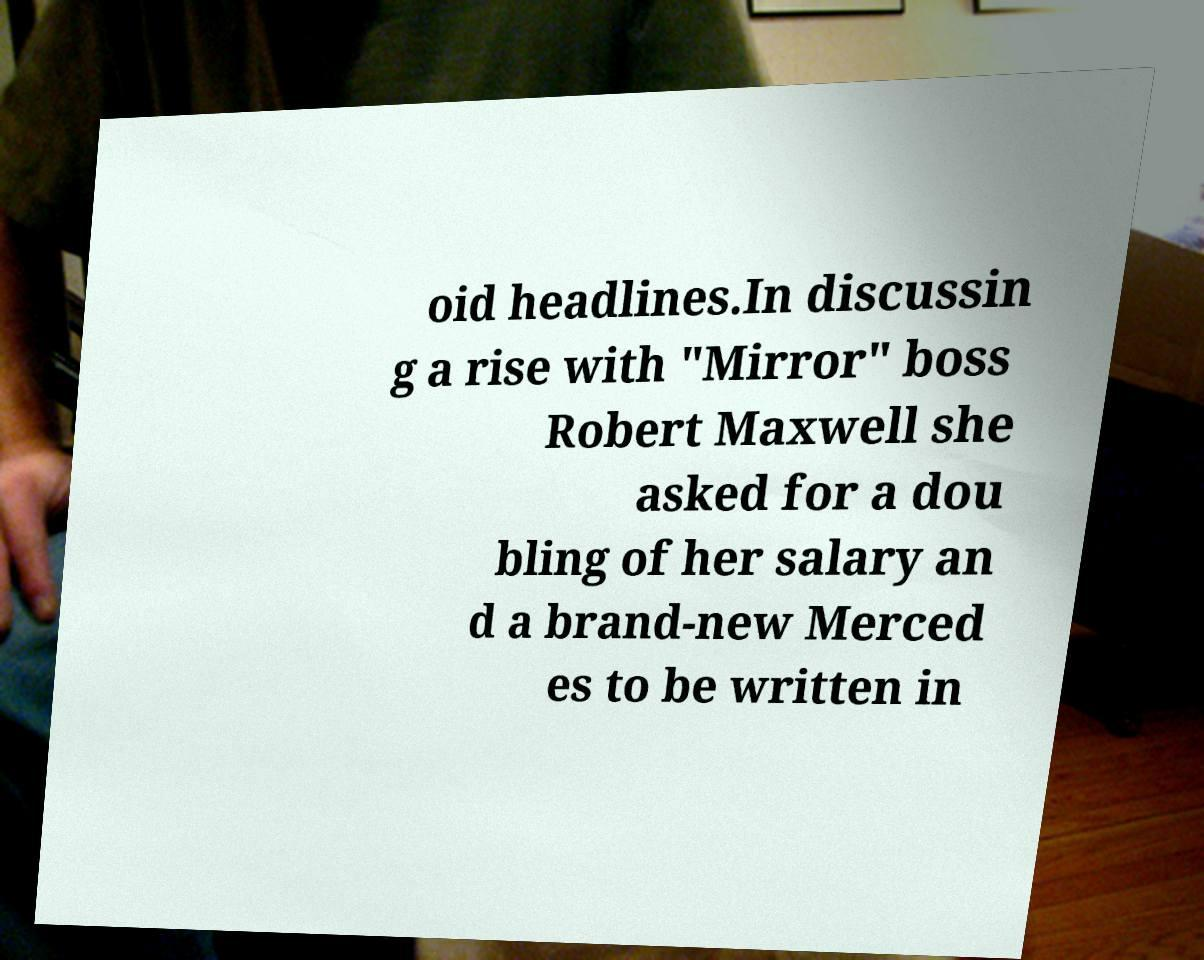Can you accurately transcribe the text from the provided image for me? oid headlines.In discussin g a rise with "Mirror" boss Robert Maxwell she asked for a dou bling of her salary an d a brand-new Merced es to be written in 